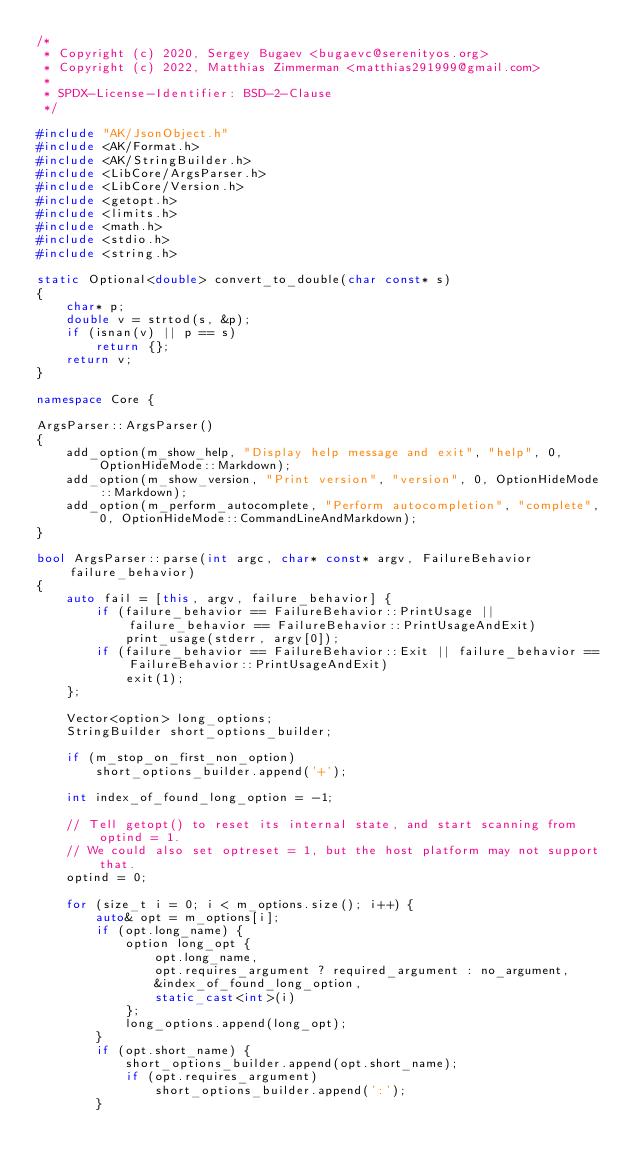Convert code to text. <code><loc_0><loc_0><loc_500><loc_500><_C++_>/*
 * Copyright (c) 2020, Sergey Bugaev <bugaevc@serenityos.org>
 * Copyright (c) 2022, Matthias Zimmerman <matthias291999@gmail.com>
 *
 * SPDX-License-Identifier: BSD-2-Clause
 */

#include "AK/JsonObject.h"
#include <AK/Format.h>
#include <AK/StringBuilder.h>
#include <LibCore/ArgsParser.h>
#include <LibCore/Version.h>
#include <getopt.h>
#include <limits.h>
#include <math.h>
#include <stdio.h>
#include <string.h>

static Optional<double> convert_to_double(char const* s)
{
    char* p;
    double v = strtod(s, &p);
    if (isnan(v) || p == s)
        return {};
    return v;
}

namespace Core {

ArgsParser::ArgsParser()
{
    add_option(m_show_help, "Display help message and exit", "help", 0, OptionHideMode::Markdown);
    add_option(m_show_version, "Print version", "version", 0, OptionHideMode::Markdown);
    add_option(m_perform_autocomplete, "Perform autocompletion", "complete", 0, OptionHideMode::CommandLineAndMarkdown);
}

bool ArgsParser::parse(int argc, char* const* argv, FailureBehavior failure_behavior)
{
    auto fail = [this, argv, failure_behavior] {
        if (failure_behavior == FailureBehavior::PrintUsage || failure_behavior == FailureBehavior::PrintUsageAndExit)
            print_usage(stderr, argv[0]);
        if (failure_behavior == FailureBehavior::Exit || failure_behavior == FailureBehavior::PrintUsageAndExit)
            exit(1);
    };

    Vector<option> long_options;
    StringBuilder short_options_builder;

    if (m_stop_on_first_non_option)
        short_options_builder.append('+');

    int index_of_found_long_option = -1;

    // Tell getopt() to reset its internal state, and start scanning from optind = 1.
    // We could also set optreset = 1, but the host platform may not support that.
    optind = 0;

    for (size_t i = 0; i < m_options.size(); i++) {
        auto& opt = m_options[i];
        if (opt.long_name) {
            option long_opt {
                opt.long_name,
                opt.requires_argument ? required_argument : no_argument,
                &index_of_found_long_option,
                static_cast<int>(i)
            };
            long_options.append(long_opt);
        }
        if (opt.short_name) {
            short_options_builder.append(opt.short_name);
            if (opt.requires_argument)
                short_options_builder.append(':');
        }</code> 